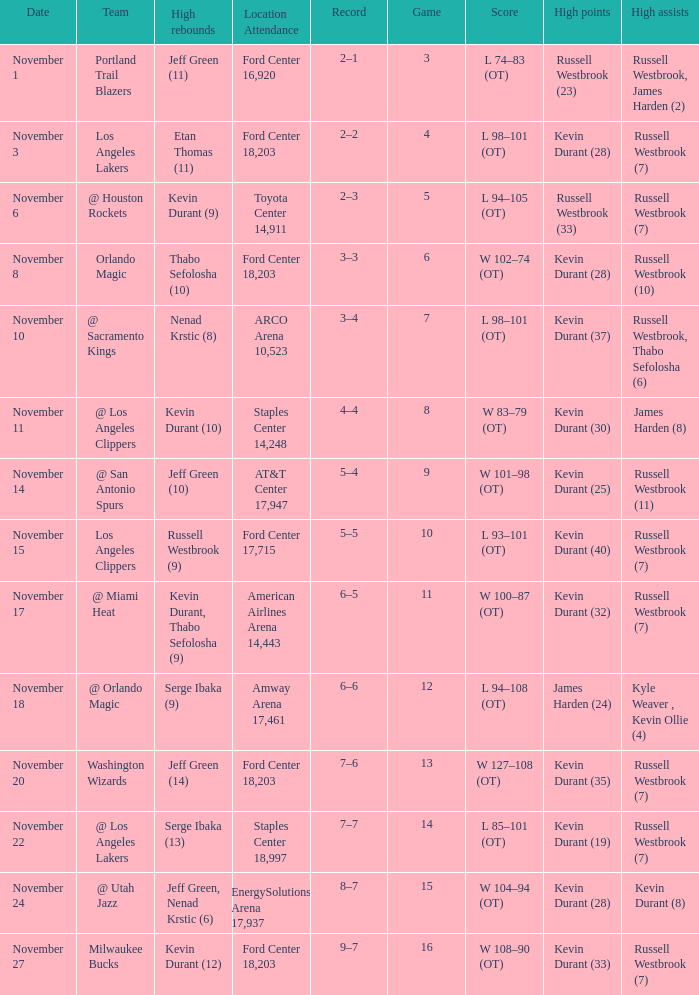What was the record in the game in which Jeff Green (14) did the most high rebounds? 7–6. Write the full table. {'header': ['Date', 'Team', 'High rebounds', 'Location Attendance', 'Record', 'Game', 'Score', 'High points', 'High assists'], 'rows': [['November 1', 'Portland Trail Blazers', 'Jeff Green (11)', 'Ford Center 16,920', '2–1', '3', 'L 74–83 (OT)', 'Russell Westbrook (23)', 'Russell Westbrook, James Harden (2)'], ['November 3', 'Los Angeles Lakers', 'Etan Thomas (11)', 'Ford Center 18,203', '2–2', '4', 'L 98–101 (OT)', 'Kevin Durant (28)', 'Russell Westbrook (7)'], ['November 6', '@ Houston Rockets', 'Kevin Durant (9)', 'Toyota Center 14,911', '2–3', '5', 'L 94–105 (OT)', 'Russell Westbrook (33)', 'Russell Westbrook (7)'], ['November 8', 'Orlando Magic', 'Thabo Sefolosha (10)', 'Ford Center 18,203', '3–3', '6', 'W 102–74 (OT)', 'Kevin Durant (28)', 'Russell Westbrook (10)'], ['November 10', '@ Sacramento Kings', 'Nenad Krstic (8)', 'ARCO Arena 10,523', '3–4', '7', 'L 98–101 (OT)', 'Kevin Durant (37)', 'Russell Westbrook, Thabo Sefolosha (6)'], ['November 11', '@ Los Angeles Clippers', 'Kevin Durant (10)', 'Staples Center 14,248', '4–4', '8', 'W 83–79 (OT)', 'Kevin Durant (30)', 'James Harden (8)'], ['November 14', '@ San Antonio Spurs', 'Jeff Green (10)', 'AT&T Center 17,947', '5–4', '9', 'W 101–98 (OT)', 'Kevin Durant (25)', 'Russell Westbrook (11)'], ['November 15', 'Los Angeles Clippers', 'Russell Westbrook (9)', 'Ford Center 17,715', '5–5', '10', 'L 93–101 (OT)', 'Kevin Durant (40)', 'Russell Westbrook (7)'], ['November 17', '@ Miami Heat', 'Kevin Durant, Thabo Sefolosha (9)', 'American Airlines Arena 14,443', '6–5', '11', 'W 100–87 (OT)', 'Kevin Durant (32)', 'Russell Westbrook (7)'], ['November 18', '@ Orlando Magic', 'Serge Ibaka (9)', 'Amway Arena 17,461', '6–6', '12', 'L 94–108 (OT)', 'James Harden (24)', 'Kyle Weaver , Kevin Ollie (4)'], ['November 20', 'Washington Wizards', 'Jeff Green (14)', 'Ford Center 18,203', '7–6', '13', 'W 127–108 (OT)', 'Kevin Durant (35)', 'Russell Westbrook (7)'], ['November 22', '@ Los Angeles Lakers', 'Serge Ibaka (13)', 'Staples Center 18,997', '7–7', '14', 'L 85–101 (OT)', 'Kevin Durant (19)', 'Russell Westbrook (7)'], ['November 24', '@ Utah Jazz', 'Jeff Green, Nenad Krstic (6)', 'EnergySolutions Arena 17,937', '8–7', '15', 'W 104–94 (OT)', 'Kevin Durant (28)', 'Kevin Durant (8)'], ['November 27', 'Milwaukee Bucks', 'Kevin Durant (12)', 'Ford Center 18,203', '9–7', '16', 'W 108–90 (OT)', 'Kevin Durant (33)', 'Russell Westbrook (7)']]} 